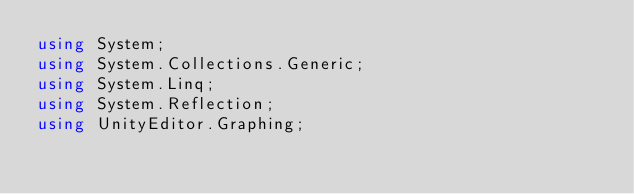Convert code to text. <code><loc_0><loc_0><loc_500><loc_500><_C#_>using System;
using System.Collections.Generic;
using System.Linq;
using System.Reflection;
using UnityEditor.Graphing;</code> 